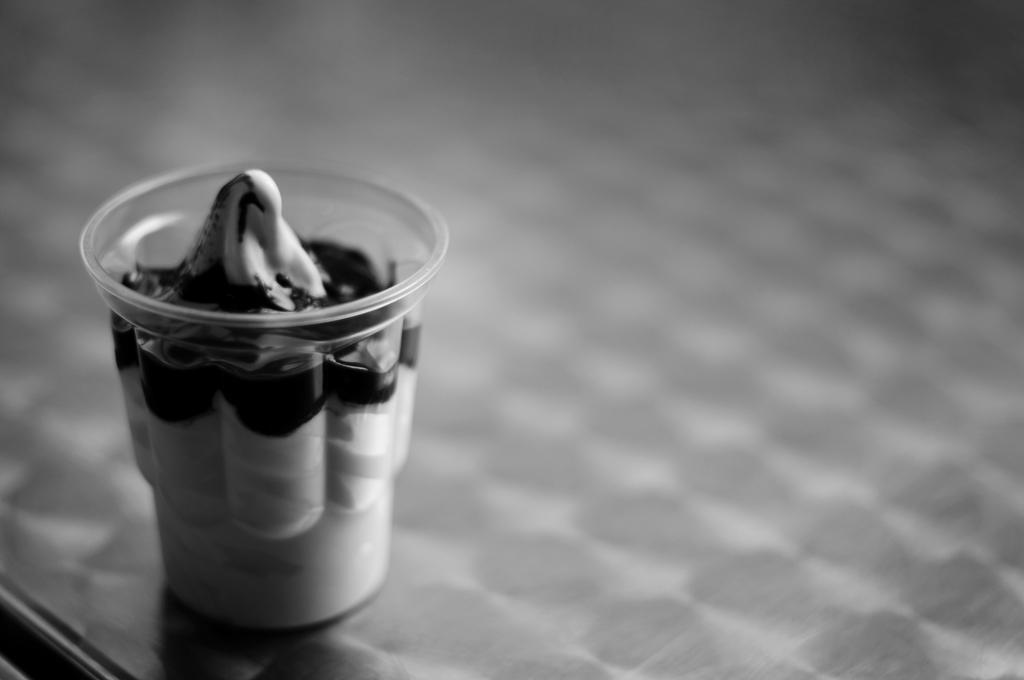What is the color scheme of the image? The image is black and white. What object can be seen in the image? There is a cup in the image. What is inside the cup? There is cream in the cup. Can you see any trails of lumber in the image? There are no trails or lumber present in the image. How many tomatoes are visible in the image? There are no tomatoes visible in the image. 